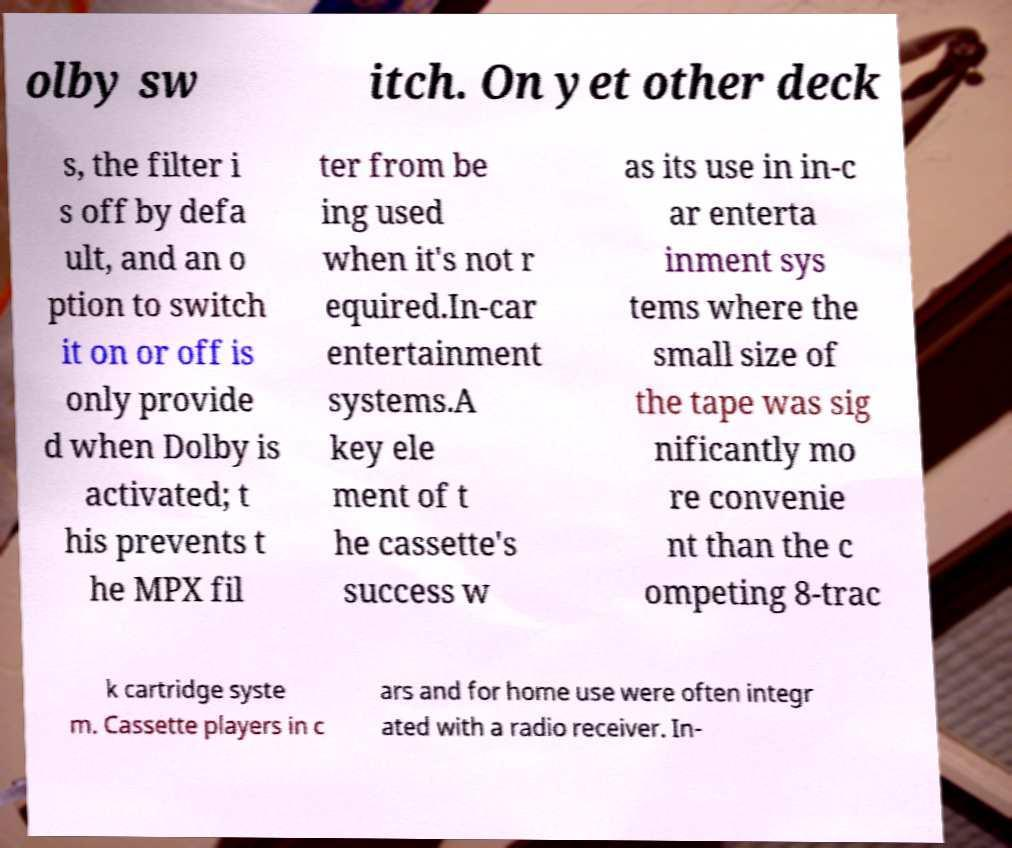There's text embedded in this image that I need extracted. Can you transcribe it verbatim? olby sw itch. On yet other deck s, the filter i s off by defa ult, and an o ption to switch it on or off is only provide d when Dolby is activated; t his prevents t he MPX fil ter from be ing used when it's not r equired.In-car entertainment systems.A key ele ment of t he cassette's success w as its use in in-c ar enterta inment sys tems where the small size of the tape was sig nificantly mo re convenie nt than the c ompeting 8-trac k cartridge syste m. Cassette players in c ars and for home use were often integr ated with a radio receiver. In- 